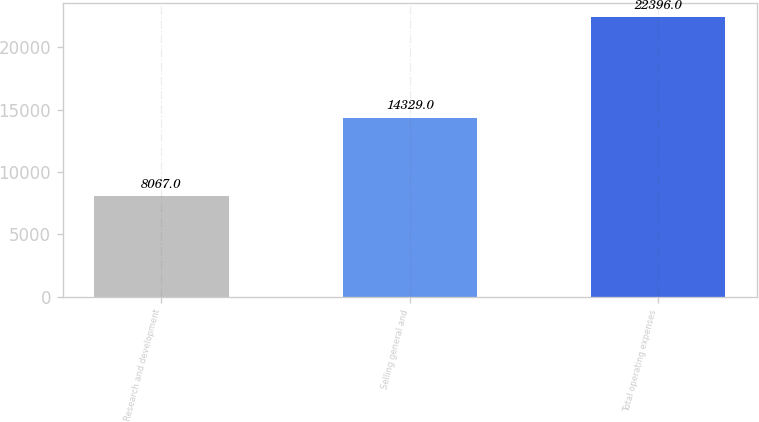Convert chart to OTSL. <chart><loc_0><loc_0><loc_500><loc_500><bar_chart><fcel>Research and development<fcel>Selling general and<fcel>Total operating expenses<nl><fcel>8067<fcel>14329<fcel>22396<nl></chart> 